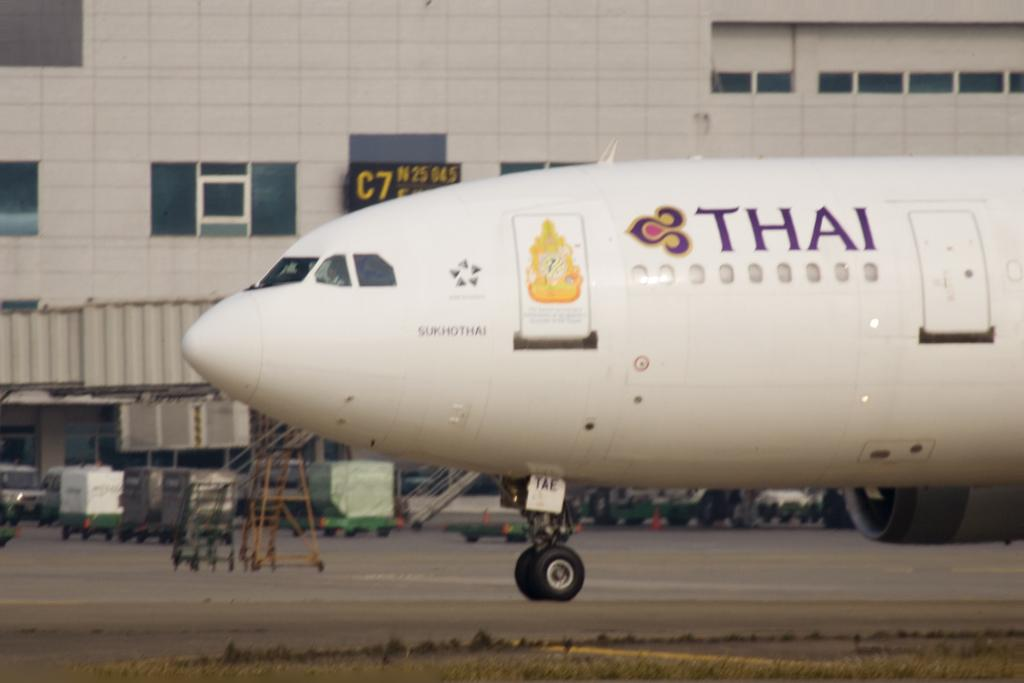What is the main subject of the picture? The main subject of the picture is an aircraft. What can be seen near the aircraft? There are metal stairs and railings visible in the picture. What type of vehicles can be seen on the surface? Vehicles are visible on the surface in the picture. What type of structure is present in the picture? There is a building in the picture. What type of windows are present in the building? There are glass windows in the picture. Can you see a house in the picture? There is no house present in the picture; it features an aircraft, metal stairs, railings, vehicles, a building, and glass windows. Is there a balloon visible in the picture? There is no balloon present in the picture. 